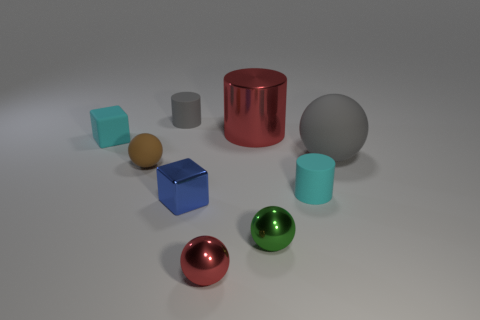Subtract all small matte cylinders. How many cylinders are left? 1 Subtract all cyan cylinders. How many cylinders are left? 2 Add 1 tiny green balls. How many objects exist? 10 Subtract 1 spheres. How many spheres are left? 3 Subtract all green cubes. Subtract all red balls. How many cubes are left? 2 Add 1 red cylinders. How many red cylinders are left? 2 Add 6 big red shiny things. How many big red shiny things exist? 7 Subtract 1 gray spheres. How many objects are left? 8 Subtract all cubes. How many objects are left? 7 Subtract all purple cubes. How many gray balls are left? 1 